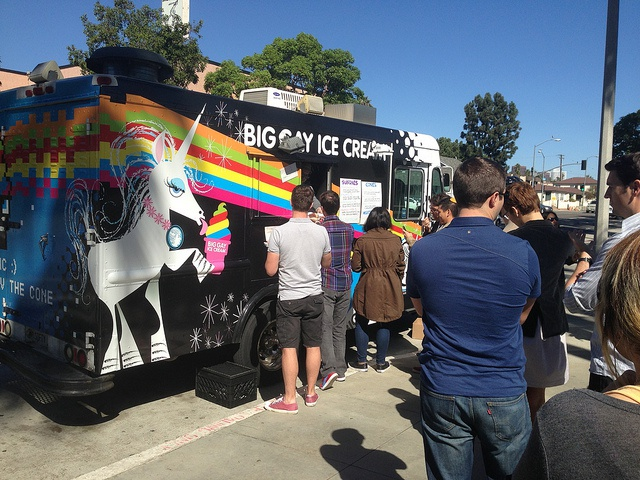Describe the objects in this image and their specific colors. I can see truck in gray, black, white, and navy tones, people in gray, navy, black, and darkblue tones, people in gray, black, and maroon tones, people in gray, lightgray, black, and tan tones, and people in gray, black, and maroon tones in this image. 